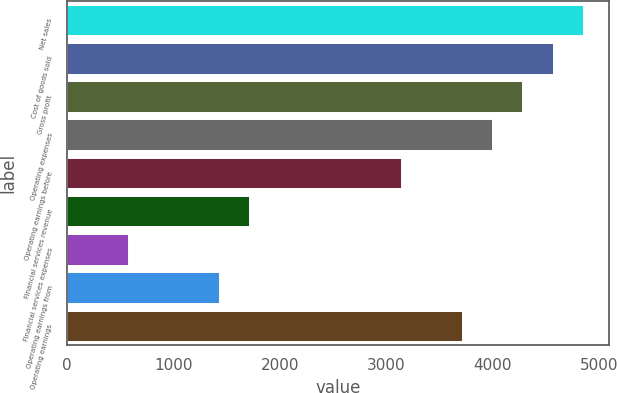Convert chart to OTSL. <chart><loc_0><loc_0><loc_500><loc_500><bar_chart><fcel>Net sales<fcel>Cost of goods sold<fcel>Gross profit<fcel>Operating expenses<fcel>Operating earnings before<fcel>Financial services revenue<fcel>Financial services expenses<fcel>Operating earnings from<fcel>Operating earnings<nl><fcel>4848.92<fcel>4563.96<fcel>4279<fcel>3994.04<fcel>3139.16<fcel>1714.36<fcel>574.52<fcel>1429.4<fcel>3709.08<nl></chart> 